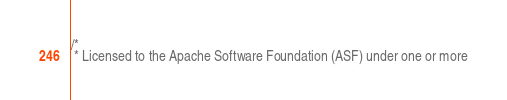Convert code to text. <code><loc_0><loc_0><loc_500><loc_500><_Scala_>/*
 * Licensed to the Apache Software Foundation (ASF) under one or more</code> 